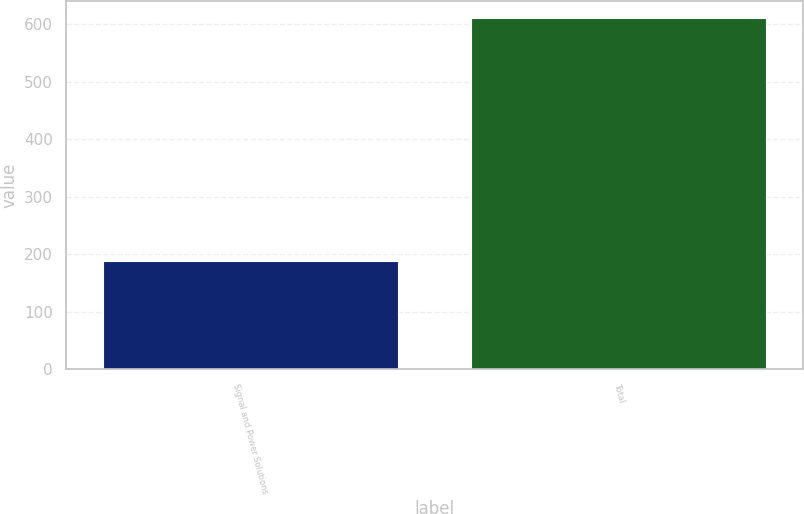Convert chart to OTSL. <chart><loc_0><loc_0><loc_500><loc_500><bar_chart><fcel>Signal and Power Solutions<fcel>Total<nl><fcel>188<fcel>610<nl></chart> 